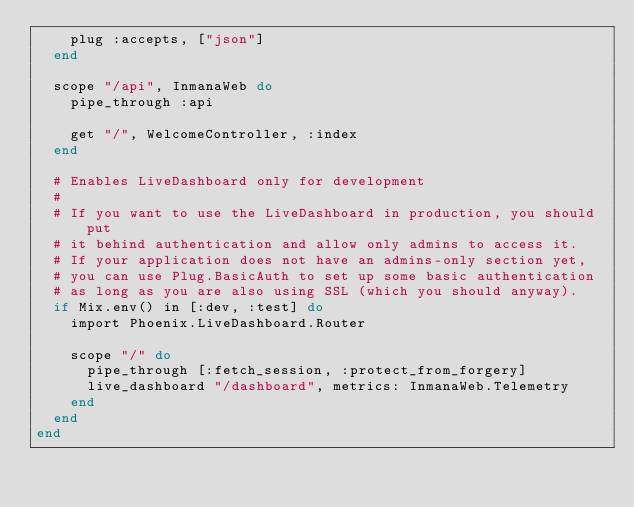<code> <loc_0><loc_0><loc_500><loc_500><_Elixir_>    plug :accepts, ["json"]
  end

  scope "/api", InmanaWeb do
    pipe_through :api

    get "/", WelcomeController, :index
  end

  # Enables LiveDashboard only for development
  #
  # If you want to use the LiveDashboard in production, you should put
  # it behind authentication and allow only admins to access it.
  # If your application does not have an admins-only section yet,
  # you can use Plug.BasicAuth to set up some basic authentication
  # as long as you are also using SSL (which you should anyway).
  if Mix.env() in [:dev, :test] do
    import Phoenix.LiveDashboard.Router

    scope "/" do
      pipe_through [:fetch_session, :protect_from_forgery]
      live_dashboard "/dashboard", metrics: InmanaWeb.Telemetry
    end
  end
end
</code> 